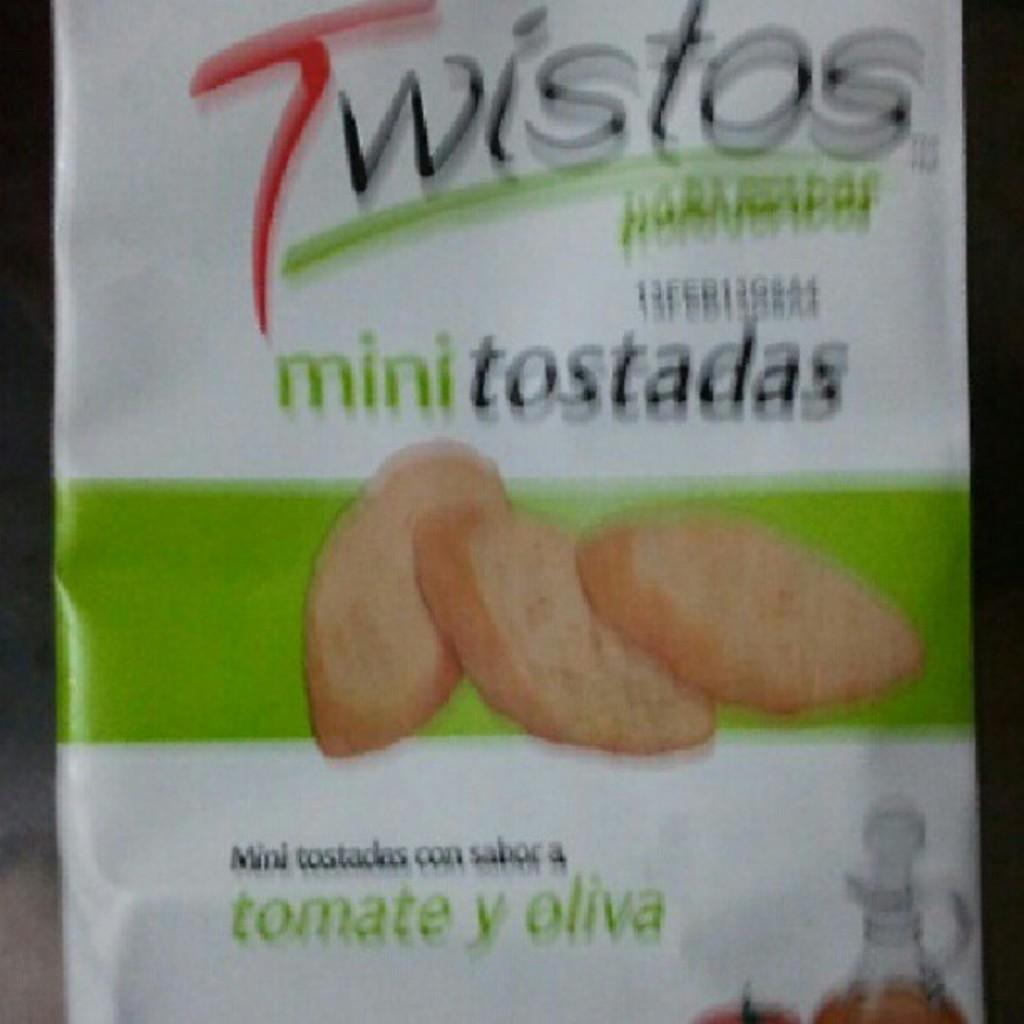What is present in the image that has text and images on it? There is a cover in the image that has text and images on it. Can you describe the text on the cover? Unfortunately, the facts provided do not give any information about the text on the cover. Can you describe the images on the cover? Unfortunately, the facts provided do not give any information about the images on the cover. How many geese are wearing vests in the image? There are no geese or vests present in the image. 